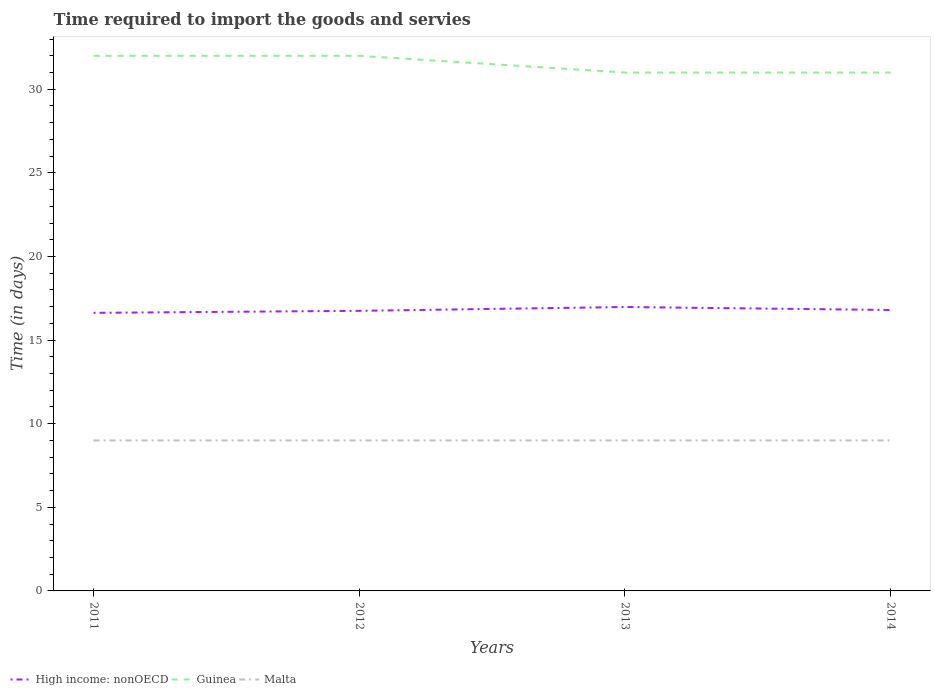Does the line corresponding to Guinea intersect with the line corresponding to Malta?
Keep it short and to the point. No. Is the number of lines equal to the number of legend labels?
Offer a very short reply. Yes. What is the total number of days required to import the goods and services in Guinea in the graph?
Your answer should be very brief. 0. How many lines are there?
Your answer should be very brief. 3. Are the values on the major ticks of Y-axis written in scientific E-notation?
Your answer should be compact. No. Does the graph contain any zero values?
Your answer should be compact. No. What is the title of the graph?
Your response must be concise. Time required to import the goods and servies. What is the label or title of the X-axis?
Provide a short and direct response. Years. What is the label or title of the Y-axis?
Your response must be concise. Time (in days). What is the Time (in days) of High income: nonOECD in 2011?
Your answer should be compact. 16.63. What is the Time (in days) of Malta in 2011?
Ensure brevity in your answer.  9. What is the Time (in days) in High income: nonOECD in 2012?
Provide a short and direct response. 16.75. What is the Time (in days) of Malta in 2012?
Give a very brief answer. 9. What is the Time (in days) in High income: nonOECD in 2013?
Ensure brevity in your answer.  16.98. What is the Time (in days) of Guinea in 2014?
Your answer should be very brief. 31. Across all years, what is the maximum Time (in days) in High income: nonOECD?
Give a very brief answer. 16.98. Across all years, what is the maximum Time (in days) of Malta?
Provide a short and direct response. 9. Across all years, what is the minimum Time (in days) of High income: nonOECD?
Provide a short and direct response. 16.63. What is the total Time (in days) in High income: nonOECD in the graph?
Offer a very short reply. 67.16. What is the total Time (in days) in Guinea in the graph?
Offer a terse response. 126. What is the total Time (in days) of Malta in the graph?
Offer a terse response. 36. What is the difference between the Time (in days) of High income: nonOECD in 2011 and that in 2012?
Make the answer very short. -0.12. What is the difference between the Time (in days) of Guinea in 2011 and that in 2012?
Offer a terse response. 0. What is the difference between the Time (in days) of High income: nonOECD in 2011 and that in 2013?
Offer a terse response. -0.35. What is the difference between the Time (in days) of High income: nonOECD in 2011 and that in 2014?
Ensure brevity in your answer.  -0.17. What is the difference between the Time (in days) in Malta in 2011 and that in 2014?
Give a very brief answer. 0. What is the difference between the Time (in days) in High income: nonOECD in 2012 and that in 2013?
Your response must be concise. -0.23. What is the difference between the Time (in days) in Malta in 2012 and that in 2013?
Your answer should be very brief. 0. What is the difference between the Time (in days) in High income: nonOECD in 2012 and that in 2014?
Offer a terse response. -0.05. What is the difference between the Time (in days) of Guinea in 2012 and that in 2014?
Your answer should be compact. 1. What is the difference between the Time (in days) in High income: nonOECD in 2013 and that in 2014?
Provide a succinct answer. 0.18. What is the difference between the Time (in days) in High income: nonOECD in 2011 and the Time (in days) in Guinea in 2012?
Make the answer very short. -15.37. What is the difference between the Time (in days) in High income: nonOECD in 2011 and the Time (in days) in Malta in 2012?
Ensure brevity in your answer.  7.63. What is the difference between the Time (in days) in High income: nonOECD in 2011 and the Time (in days) in Guinea in 2013?
Ensure brevity in your answer.  -14.37. What is the difference between the Time (in days) in High income: nonOECD in 2011 and the Time (in days) in Malta in 2013?
Offer a very short reply. 7.63. What is the difference between the Time (in days) in Guinea in 2011 and the Time (in days) in Malta in 2013?
Provide a succinct answer. 23. What is the difference between the Time (in days) of High income: nonOECD in 2011 and the Time (in days) of Guinea in 2014?
Offer a terse response. -14.37. What is the difference between the Time (in days) in High income: nonOECD in 2011 and the Time (in days) in Malta in 2014?
Provide a succinct answer. 7.63. What is the difference between the Time (in days) in Guinea in 2011 and the Time (in days) in Malta in 2014?
Provide a short and direct response. 23. What is the difference between the Time (in days) in High income: nonOECD in 2012 and the Time (in days) in Guinea in 2013?
Ensure brevity in your answer.  -14.25. What is the difference between the Time (in days) of High income: nonOECD in 2012 and the Time (in days) of Malta in 2013?
Provide a short and direct response. 7.75. What is the difference between the Time (in days) of High income: nonOECD in 2012 and the Time (in days) of Guinea in 2014?
Your answer should be compact. -14.25. What is the difference between the Time (in days) of High income: nonOECD in 2012 and the Time (in days) of Malta in 2014?
Provide a short and direct response. 7.75. What is the difference between the Time (in days) in Guinea in 2012 and the Time (in days) in Malta in 2014?
Offer a very short reply. 23. What is the difference between the Time (in days) of High income: nonOECD in 2013 and the Time (in days) of Guinea in 2014?
Keep it short and to the point. -14.02. What is the difference between the Time (in days) in High income: nonOECD in 2013 and the Time (in days) in Malta in 2014?
Ensure brevity in your answer.  7.98. What is the difference between the Time (in days) in Guinea in 2013 and the Time (in days) in Malta in 2014?
Your answer should be compact. 22. What is the average Time (in days) of High income: nonOECD per year?
Your response must be concise. 16.79. What is the average Time (in days) in Guinea per year?
Offer a terse response. 31.5. What is the average Time (in days) of Malta per year?
Provide a succinct answer. 9. In the year 2011, what is the difference between the Time (in days) of High income: nonOECD and Time (in days) of Guinea?
Give a very brief answer. -15.37. In the year 2011, what is the difference between the Time (in days) of High income: nonOECD and Time (in days) of Malta?
Give a very brief answer. 7.63. In the year 2011, what is the difference between the Time (in days) of Guinea and Time (in days) of Malta?
Provide a short and direct response. 23. In the year 2012, what is the difference between the Time (in days) of High income: nonOECD and Time (in days) of Guinea?
Offer a very short reply. -15.25. In the year 2012, what is the difference between the Time (in days) in High income: nonOECD and Time (in days) in Malta?
Keep it short and to the point. 7.75. In the year 2012, what is the difference between the Time (in days) in Guinea and Time (in days) in Malta?
Your response must be concise. 23. In the year 2013, what is the difference between the Time (in days) of High income: nonOECD and Time (in days) of Guinea?
Give a very brief answer. -14.02. In the year 2013, what is the difference between the Time (in days) in High income: nonOECD and Time (in days) in Malta?
Ensure brevity in your answer.  7.98. In the year 2013, what is the difference between the Time (in days) in Guinea and Time (in days) in Malta?
Ensure brevity in your answer.  22. What is the ratio of the Time (in days) of Guinea in 2011 to that in 2012?
Make the answer very short. 1. What is the ratio of the Time (in days) in Malta in 2011 to that in 2012?
Provide a short and direct response. 1. What is the ratio of the Time (in days) in High income: nonOECD in 2011 to that in 2013?
Offer a very short reply. 0.98. What is the ratio of the Time (in days) in Guinea in 2011 to that in 2013?
Ensure brevity in your answer.  1.03. What is the ratio of the Time (in days) of Malta in 2011 to that in 2013?
Keep it short and to the point. 1. What is the ratio of the Time (in days) of Guinea in 2011 to that in 2014?
Your answer should be compact. 1.03. What is the ratio of the Time (in days) in High income: nonOECD in 2012 to that in 2013?
Offer a very short reply. 0.99. What is the ratio of the Time (in days) in Guinea in 2012 to that in 2013?
Your answer should be compact. 1.03. What is the ratio of the Time (in days) of Malta in 2012 to that in 2013?
Give a very brief answer. 1. What is the ratio of the Time (in days) in High income: nonOECD in 2012 to that in 2014?
Make the answer very short. 1. What is the ratio of the Time (in days) in Guinea in 2012 to that in 2014?
Make the answer very short. 1.03. What is the ratio of the Time (in days) in Malta in 2012 to that in 2014?
Ensure brevity in your answer.  1. What is the ratio of the Time (in days) of High income: nonOECD in 2013 to that in 2014?
Offer a very short reply. 1.01. What is the difference between the highest and the second highest Time (in days) of High income: nonOECD?
Ensure brevity in your answer.  0.18. What is the difference between the highest and the lowest Time (in days) in High income: nonOECD?
Ensure brevity in your answer.  0.35. 